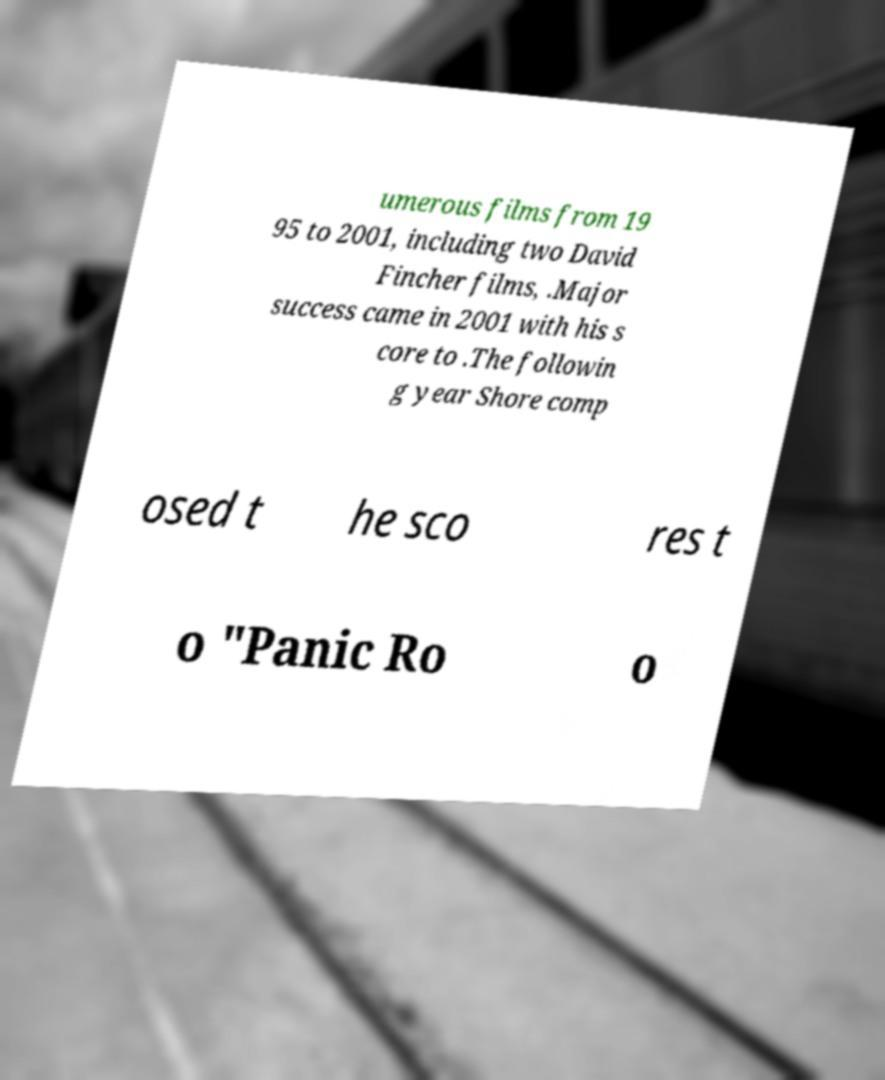Could you extract and type out the text from this image? umerous films from 19 95 to 2001, including two David Fincher films, .Major success came in 2001 with his s core to .The followin g year Shore comp osed t he sco res t o "Panic Ro o 